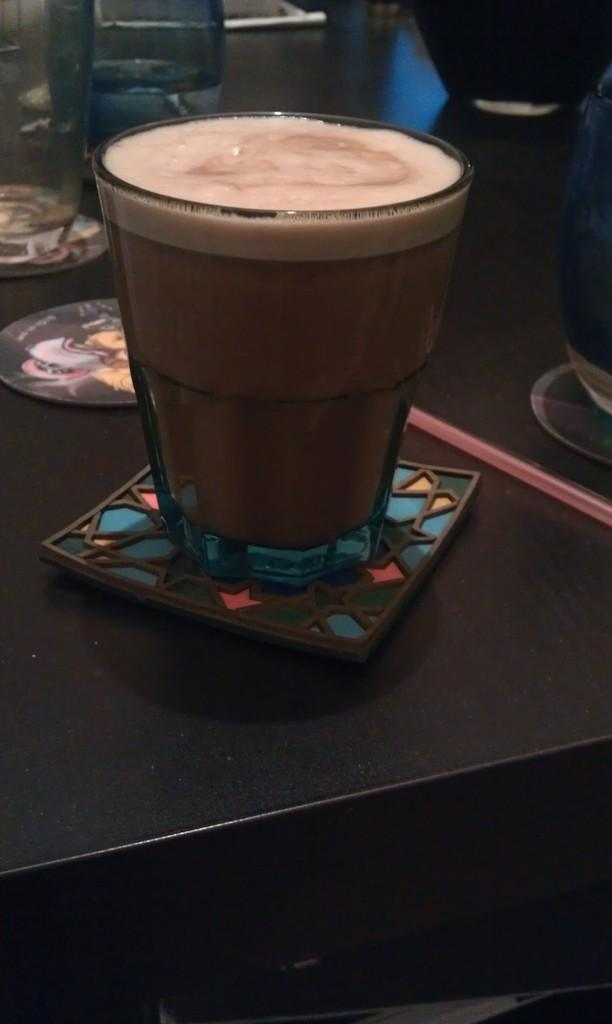What is on the table in the image? There is a glass with a drink in it on a table. Can you describe any objects visible in the background of the image? Unfortunately, the provided facts do not give any information about the objects visible in the background of the image. What type of protest is happening in the image? There is no protest present in the image; it only features a glass with a drink on a table. 